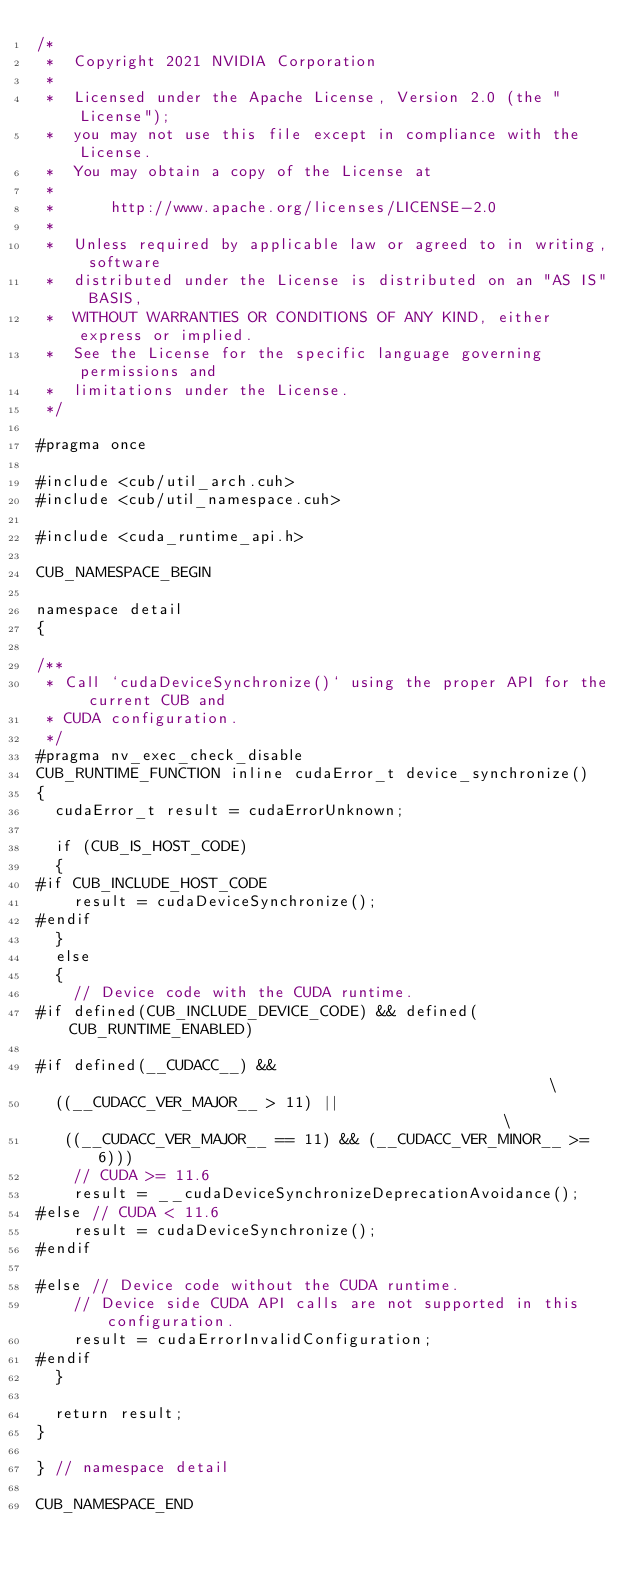Convert code to text. <code><loc_0><loc_0><loc_500><loc_500><_Cuda_>/*
 *  Copyright 2021 NVIDIA Corporation
 *
 *  Licensed under the Apache License, Version 2.0 (the "License");
 *  you may not use this file except in compliance with the License.
 *  You may obtain a copy of the License at
 *
 *      http://www.apache.org/licenses/LICENSE-2.0
 *
 *  Unless required by applicable law or agreed to in writing, software
 *  distributed under the License is distributed on an "AS IS" BASIS,
 *  WITHOUT WARRANTIES OR CONDITIONS OF ANY KIND, either express or implied.
 *  See the License for the specific language governing permissions and
 *  limitations under the License.
 */

#pragma once

#include <cub/util_arch.cuh>
#include <cub/util_namespace.cuh>

#include <cuda_runtime_api.h>

CUB_NAMESPACE_BEGIN

namespace detail
{

/**
 * Call `cudaDeviceSynchronize()` using the proper API for the current CUB and
 * CUDA configuration.
 */
#pragma nv_exec_check_disable
CUB_RUNTIME_FUNCTION inline cudaError_t device_synchronize()
{
  cudaError_t result = cudaErrorUnknown;

  if (CUB_IS_HOST_CODE)
  {
#if CUB_INCLUDE_HOST_CODE
    result = cudaDeviceSynchronize();
#endif
  }
  else
  {
    // Device code with the CUDA runtime.
#if defined(CUB_INCLUDE_DEVICE_CODE) && defined(CUB_RUNTIME_ENABLED)

#if defined(__CUDACC__) &&                                                     \
  ((__CUDACC_VER_MAJOR__ > 11) ||                                              \
   ((__CUDACC_VER_MAJOR__ == 11) && (__CUDACC_VER_MINOR__ >= 6)))
    // CUDA >= 11.6
    result = __cudaDeviceSynchronizeDeprecationAvoidance();
#else // CUDA < 11.6
    result = cudaDeviceSynchronize();
#endif

#else // Device code without the CUDA runtime.
    // Device side CUDA API calls are not supported in this configuration.
    result = cudaErrorInvalidConfiguration;
#endif
  }

  return result;
}

} // namespace detail

CUB_NAMESPACE_END
</code> 